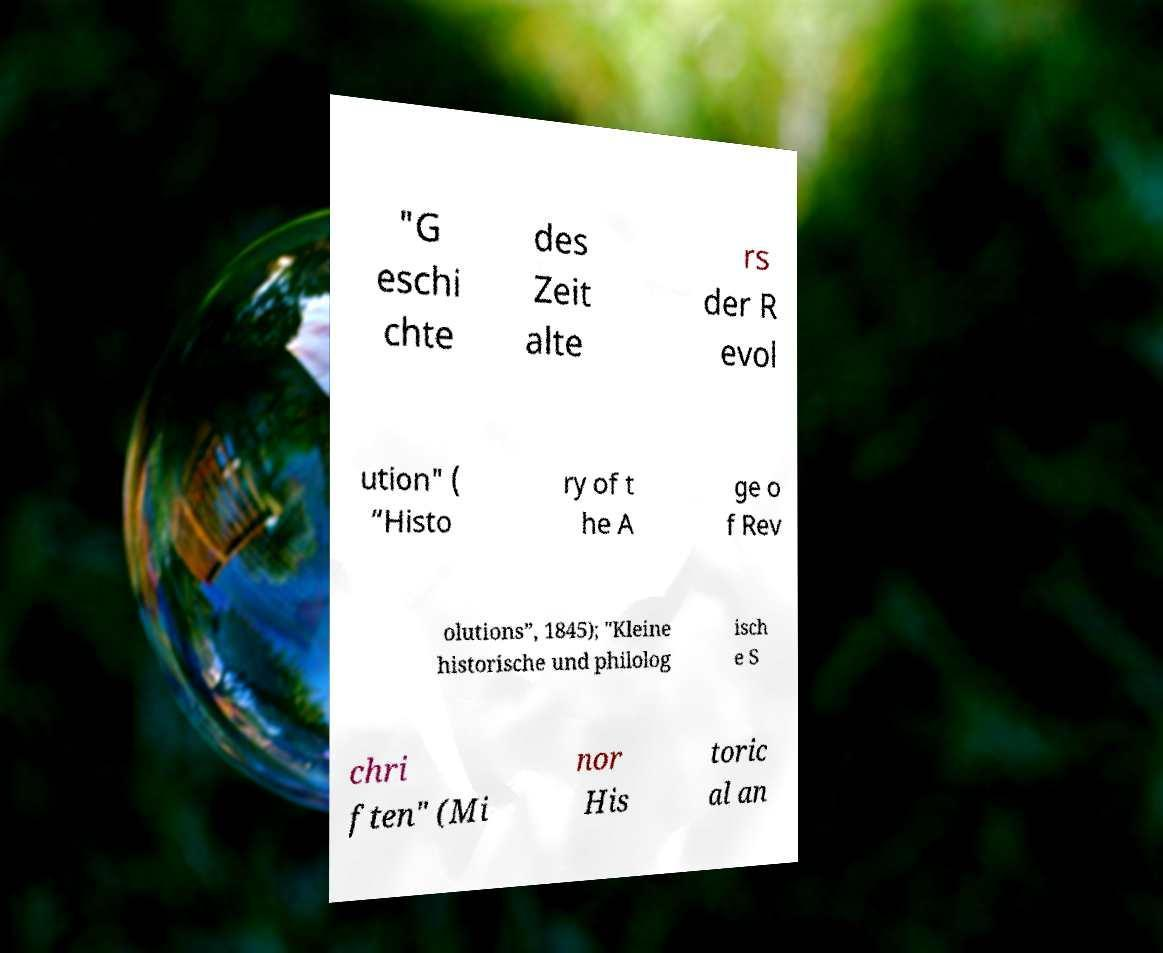Can you read and provide the text displayed in the image?This photo seems to have some interesting text. Can you extract and type it out for me? "G eschi chte des Zeit alte rs der R evol ution" ( “Histo ry of t he A ge o f Rev olutions”, 1845); "Kleine historische und philolog isch e S chri ften" (Mi nor His toric al an 